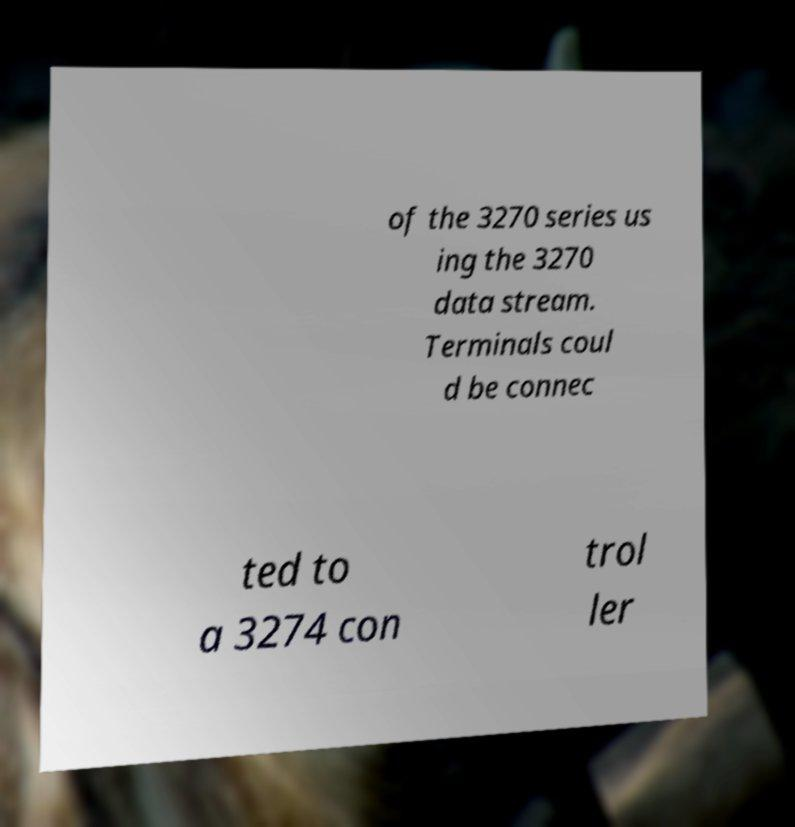Please read and relay the text visible in this image. What does it say? of the 3270 series us ing the 3270 data stream. Terminals coul d be connec ted to a 3274 con trol ler 